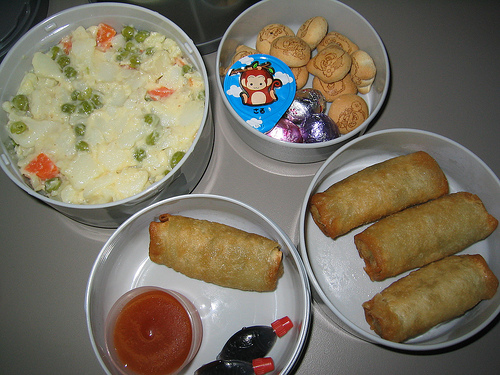<image>
Can you confirm if the monkey is in the bowl? Yes. The monkey is contained within or inside the bowl, showing a containment relationship. 